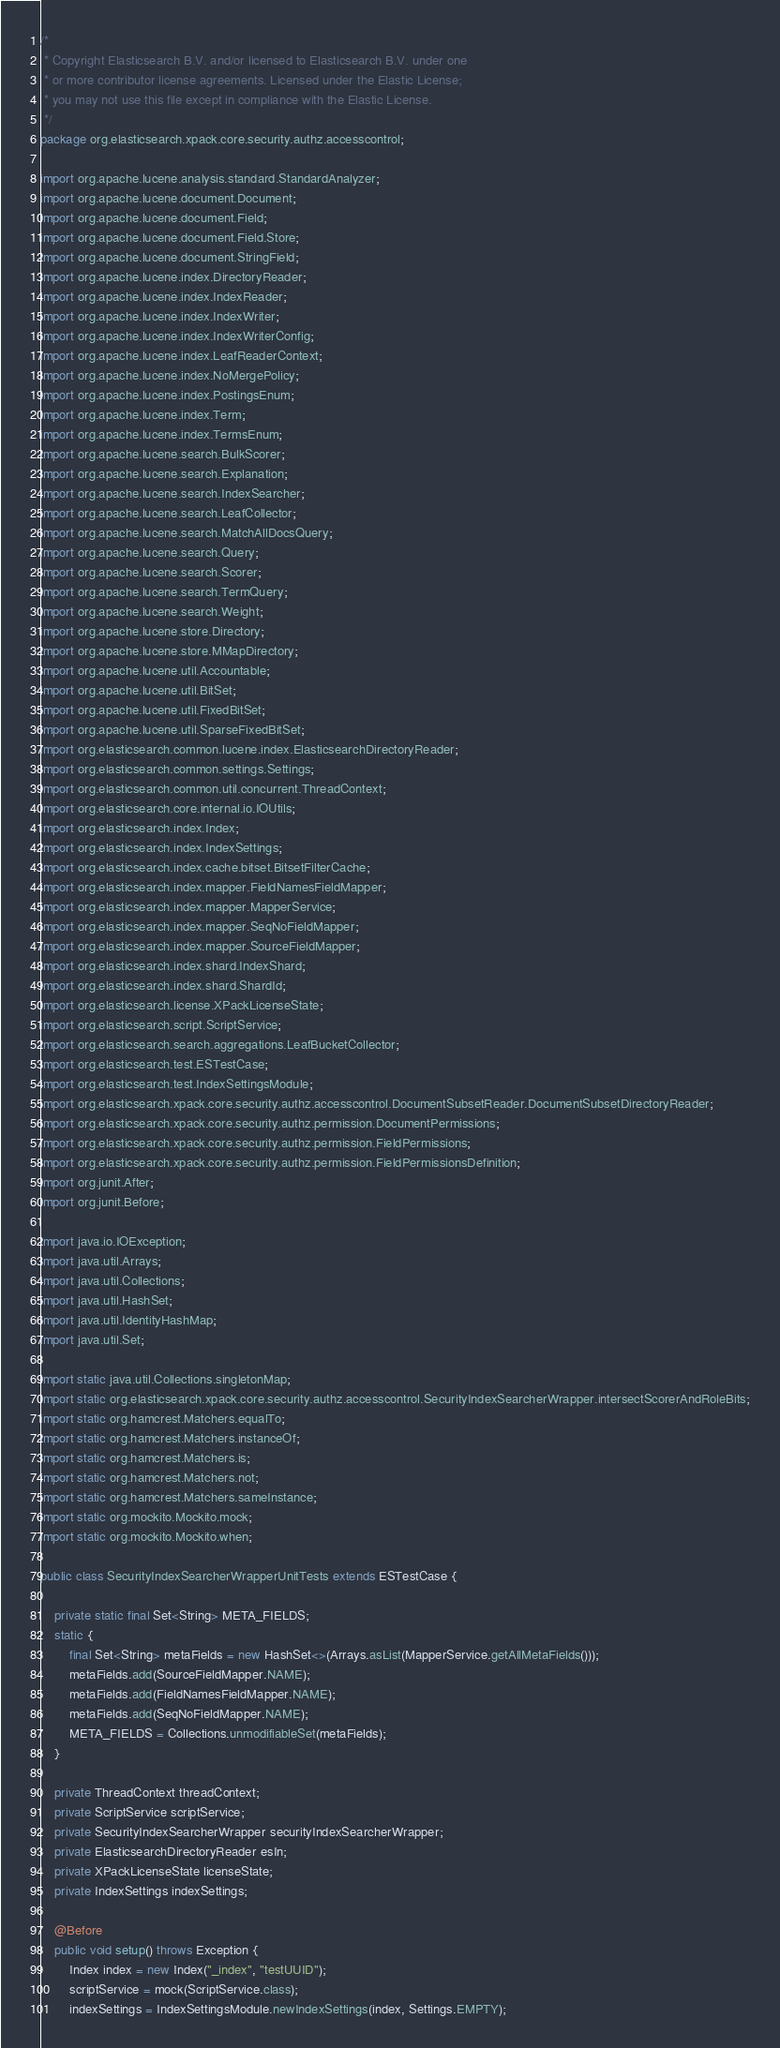Convert code to text. <code><loc_0><loc_0><loc_500><loc_500><_Java_>/*
 * Copyright Elasticsearch B.V. and/or licensed to Elasticsearch B.V. under one
 * or more contributor license agreements. Licensed under the Elastic License;
 * you may not use this file except in compliance with the Elastic License.
 */
package org.elasticsearch.xpack.core.security.authz.accesscontrol;

import org.apache.lucene.analysis.standard.StandardAnalyzer;
import org.apache.lucene.document.Document;
import org.apache.lucene.document.Field;
import org.apache.lucene.document.Field.Store;
import org.apache.lucene.document.StringField;
import org.apache.lucene.index.DirectoryReader;
import org.apache.lucene.index.IndexReader;
import org.apache.lucene.index.IndexWriter;
import org.apache.lucene.index.IndexWriterConfig;
import org.apache.lucene.index.LeafReaderContext;
import org.apache.lucene.index.NoMergePolicy;
import org.apache.lucene.index.PostingsEnum;
import org.apache.lucene.index.Term;
import org.apache.lucene.index.TermsEnum;
import org.apache.lucene.search.BulkScorer;
import org.apache.lucene.search.Explanation;
import org.apache.lucene.search.IndexSearcher;
import org.apache.lucene.search.LeafCollector;
import org.apache.lucene.search.MatchAllDocsQuery;
import org.apache.lucene.search.Query;
import org.apache.lucene.search.Scorer;
import org.apache.lucene.search.TermQuery;
import org.apache.lucene.search.Weight;
import org.apache.lucene.store.Directory;
import org.apache.lucene.store.MMapDirectory;
import org.apache.lucene.util.Accountable;
import org.apache.lucene.util.BitSet;
import org.apache.lucene.util.FixedBitSet;
import org.apache.lucene.util.SparseFixedBitSet;
import org.elasticsearch.common.lucene.index.ElasticsearchDirectoryReader;
import org.elasticsearch.common.settings.Settings;
import org.elasticsearch.common.util.concurrent.ThreadContext;
import org.elasticsearch.core.internal.io.IOUtils;
import org.elasticsearch.index.Index;
import org.elasticsearch.index.IndexSettings;
import org.elasticsearch.index.cache.bitset.BitsetFilterCache;
import org.elasticsearch.index.mapper.FieldNamesFieldMapper;
import org.elasticsearch.index.mapper.MapperService;
import org.elasticsearch.index.mapper.SeqNoFieldMapper;
import org.elasticsearch.index.mapper.SourceFieldMapper;
import org.elasticsearch.index.shard.IndexShard;
import org.elasticsearch.index.shard.ShardId;
import org.elasticsearch.license.XPackLicenseState;
import org.elasticsearch.script.ScriptService;
import org.elasticsearch.search.aggregations.LeafBucketCollector;
import org.elasticsearch.test.ESTestCase;
import org.elasticsearch.test.IndexSettingsModule;
import org.elasticsearch.xpack.core.security.authz.accesscontrol.DocumentSubsetReader.DocumentSubsetDirectoryReader;
import org.elasticsearch.xpack.core.security.authz.permission.DocumentPermissions;
import org.elasticsearch.xpack.core.security.authz.permission.FieldPermissions;
import org.elasticsearch.xpack.core.security.authz.permission.FieldPermissionsDefinition;
import org.junit.After;
import org.junit.Before;

import java.io.IOException;
import java.util.Arrays;
import java.util.Collections;
import java.util.HashSet;
import java.util.IdentityHashMap;
import java.util.Set;

import static java.util.Collections.singletonMap;
import static org.elasticsearch.xpack.core.security.authz.accesscontrol.SecurityIndexSearcherWrapper.intersectScorerAndRoleBits;
import static org.hamcrest.Matchers.equalTo;
import static org.hamcrest.Matchers.instanceOf;
import static org.hamcrest.Matchers.is;
import static org.hamcrest.Matchers.not;
import static org.hamcrest.Matchers.sameInstance;
import static org.mockito.Mockito.mock;
import static org.mockito.Mockito.when;

public class SecurityIndexSearcherWrapperUnitTests extends ESTestCase {

    private static final Set<String> META_FIELDS;
    static {
        final Set<String> metaFields = new HashSet<>(Arrays.asList(MapperService.getAllMetaFields()));
        metaFields.add(SourceFieldMapper.NAME);
        metaFields.add(FieldNamesFieldMapper.NAME);
        metaFields.add(SeqNoFieldMapper.NAME);
        META_FIELDS = Collections.unmodifiableSet(metaFields);
    }

    private ThreadContext threadContext;
    private ScriptService scriptService;
    private SecurityIndexSearcherWrapper securityIndexSearcherWrapper;
    private ElasticsearchDirectoryReader esIn;
    private XPackLicenseState licenseState;
    private IndexSettings indexSettings;

    @Before
    public void setup() throws Exception {
        Index index = new Index("_index", "testUUID");
        scriptService = mock(ScriptService.class);
        indexSettings = IndexSettingsModule.newIndexSettings(index, Settings.EMPTY);
</code> 